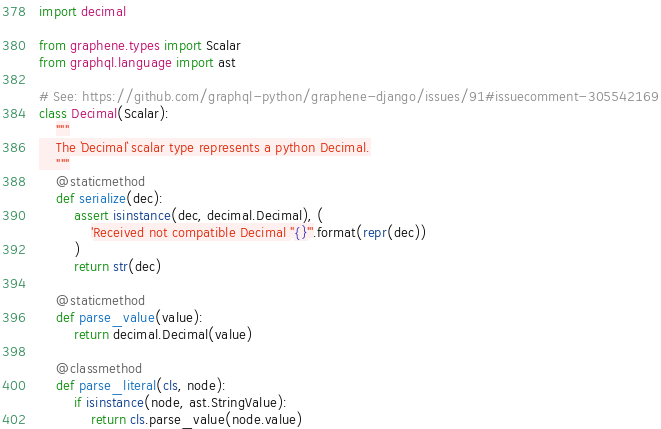Convert code to text. <code><loc_0><loc_0><loc_500><loc_500><_Python_>import decimal

from graphene.types import Scalar
from graphql.language import ast

# See: https://github.com/graphql-python/graphene-django/issues/91#issuecomment-305542169
class Decimal(Scalar):
    """
    The `Decimal` scalar type represents a python Decimal.
    """
    @staticmethod
    def serialize(dec):
        assert isinstance(dec, decimal.Decimal), (
            'Received not compatible Decimal "{}"'.format(repr(dec))
        )
        return str(dec)

    @staticmethod
    def parse_value(value):
        return decimal.Decimal(value)

    @classmethod
    def parse_literal(cls, node):
        if isinstance(node, ast.StringValue):
            return cls.parse_value(node.value)
</code> 